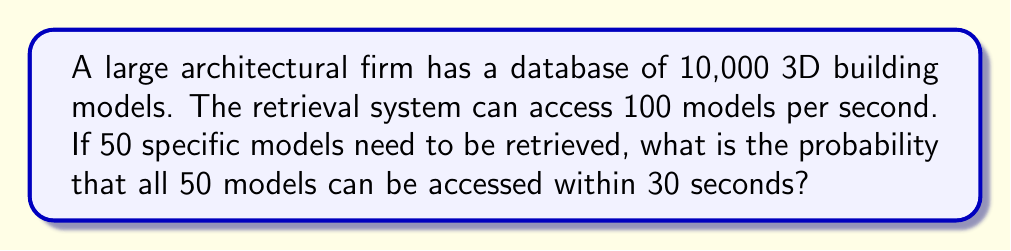Can you solve this math problem? Let's approach this step-by-step:

1) First, we need to calculate how many models can be accessed in 30 seconds:
   $100 \text{ models/second} \times 30 \text{ seconds} = 3000 \text{ models}$

2) Now, we have a situation where we're selecting 50 specific models out of 3000, and we want all of these to be among the 10,000 total models.

3) This is a hypergeometric distribution problem. We can calculate the probability using the following formula:

   $$P(\text{all 50 in 3000}) = \frac{\binom{3000}{50}}{\binom{10000}{50}}$$

4) Here, $\binom{3000}{50}$ represents the number of ways to choose 50 models from 3000, and $\binom{10000}{50}$ represents the number of ways to choose 50 models from 10,000.

5) We can calculate this using the following steps:

   $$P = \frac{3000! \times 9950!}{2950! \times 10000!}$$

6) This can be simplified to:

   $$P = \frac{3000 \times 2999 \times 2998 \times ... \times 2951}{10000 \times 9999 \times 9998 \times ... \times 9951}$$

7) Calculating this (which would typically be done with a computer due to the large numbers involved) gives us:

   $$P \approx 0.0136$$

8) Therefore, the probability is approximately 1.36% or 0.0136.
Answer: $0.0136$ 